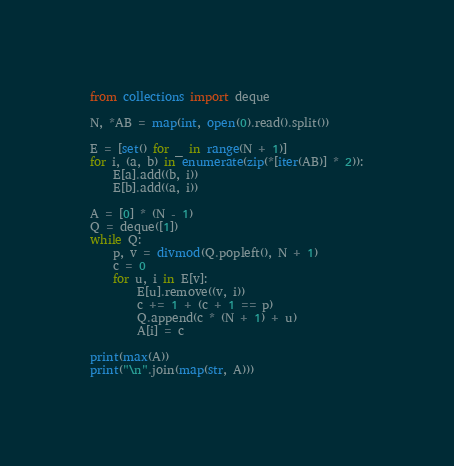Convert code to text. <code><loc_0><loc_0><loc_500><loc_500><_Python_>from collections import deque

N, *AB = map(int, open(0).read().split())

E = [set() for _ in range(N + 1)]
for i, (a, b) in enumerate(zip(*[iter(AB)] * 2)):
    E[a].add((b, i))
    E[b].add((a, i))

A = [0] * (N - 1)
Q = deque([1])
while Q:
    p, v = divmod(Q.popleft(), N + 1)
    c = 0
    for u, i in E[v]:
        E[u].remove((v, i))
        c += 1 + (c + 1 == p)
        Q.append(c * (N + 1) + u)
        A[i] = c

print(max(A))
print("\n".join(map(str, A)))</code> 